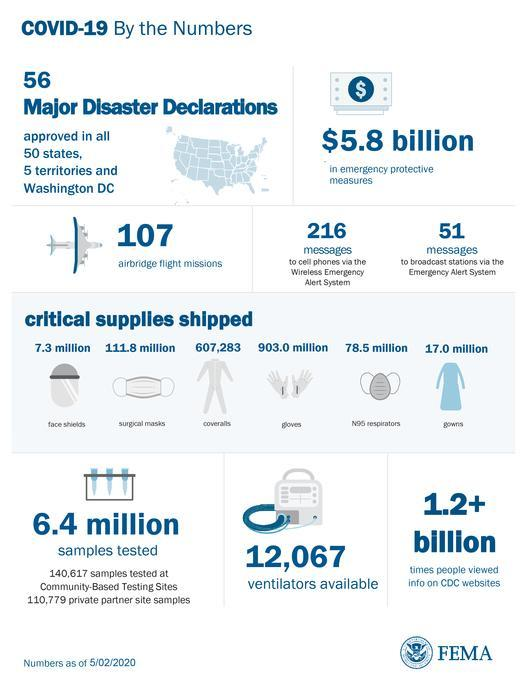How many samples were tested in total
Answer the question with a short phrase. 6.4 million What is the total count in Millions of face shields and gowns shipped 24.3 How many gowns have been shipped 17.0 million How many messages  have come to cell phones via the wireless emergency alert system 216 78.5 million of what was shipped N95 respirators 